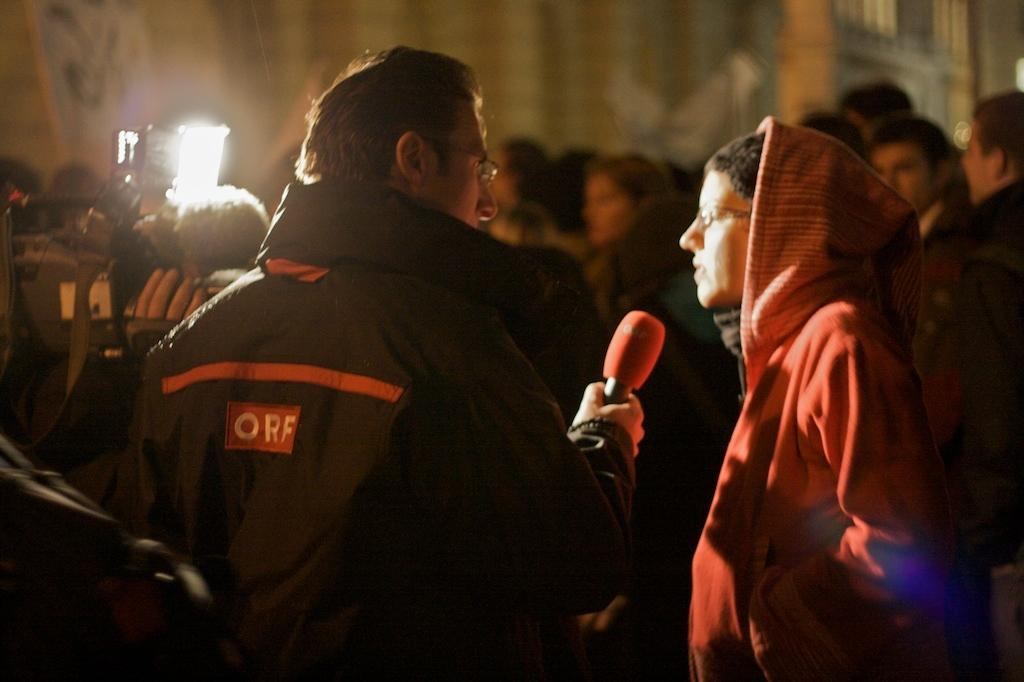How many people are in the image? There are people in the image. What are the people in the image doing? One person is holding a microphone, and another person is holding a video camera. Can you describe the background of the image? The background of the image is blurred. What type of flowers can be seen in the image? There are no flowers present in the image. How many bones are visible in the image? There are no bones visible in the image. 